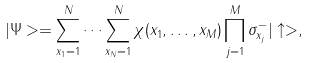<formula> <loc_0><loc_0><loc_500><loc_500>| \Psi > = \sum _ { x _ { 1 } = 1 } ^ { N } \cdots \sum _ { x _ { N } = 1 } ^ { N } \chi ( x _ { 1 } , \dots , x _ { M } ) \prod _ { j = 1 } ^ { M } \sigma _ { x _ { j } } ^ { - } | \uparrow > ,</formula> 